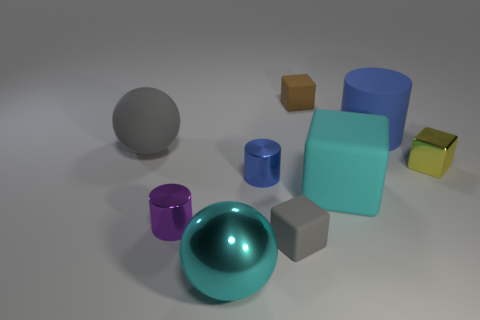Subtract all small blue metallic cylinders. How many cylinders are left? 2 Add 1 tiny purple objects. How many objects exist? 10 Subtract all yellow cubes. How many cubes are left? 3 Subtract all cylinders. How many objects are left? 6 Subtract all green cubes. How many purple spheres are left? 0 Subtract 0 purple spheres. How many objects are left? 9 Subtract 2 cylinders. How many cylinders are left? 1 Subtract all green spheres. Subtract all purple cylinders. How many spheres are left? 2 Subtract all small rubber objects. Subtract all large red rubber objects. How many objects are left? 7 Add 8 yellow blocks. How many yellow blocks are left? 9 